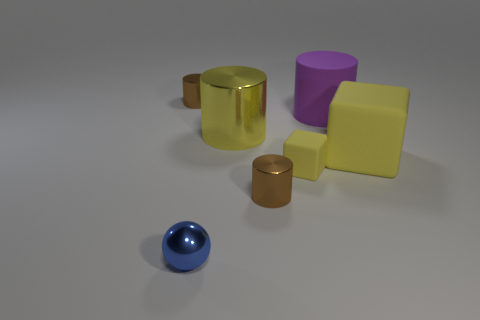Subtract all green cylinders. Subtract all gray blocks. How many cylinders are left? 4 Add 1 tiny brown objects. How many objects exist? 8 Subtract all cylinders. How many objects are left? 3 Subtract all rubber objects. Subtract all tiny shiny balls. How many objects are left? 3 Add 7 big yellow shiny things. How many big yellow shiny things are left? 8 Add 5 tiny brown metallic cylinders. How many tiny brown metallic cylinders exist? 7 Subtract 0 blue cubes. How many objects are left? 7 